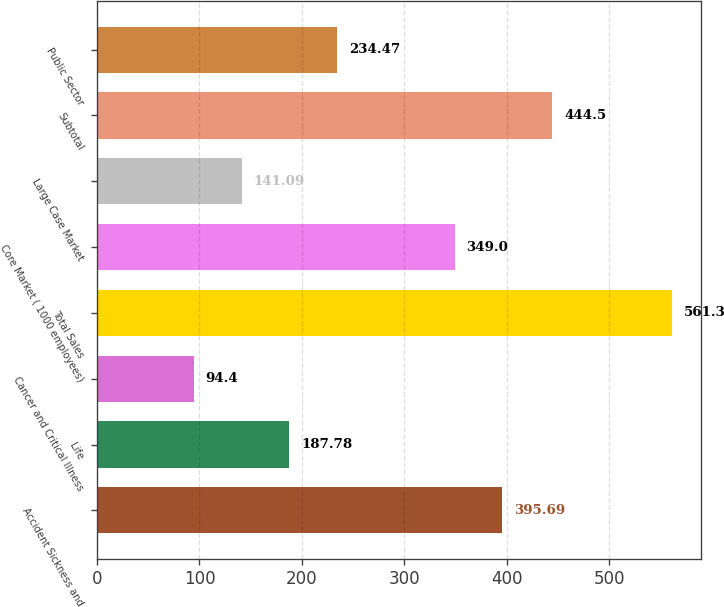Convert chart. <chart><loc_0><loc_0><loc_500><loc_500><bar_chart><fcel>Accident Sickness and<fcel>Life<fcel>Cancer and Critical Illness<fcel>Total Sales<fcel>Core Market ( 1000 employees)<fcel>Large Case Market<fcel>Subtotal<fcel>Public Sector<nl><fcel>395.69<fcel>187.78<fcel>94.4<fcel>561.3<fcel>349<fcel>141.09<fcel>444.5<fcel>234.47<nl></chart> 